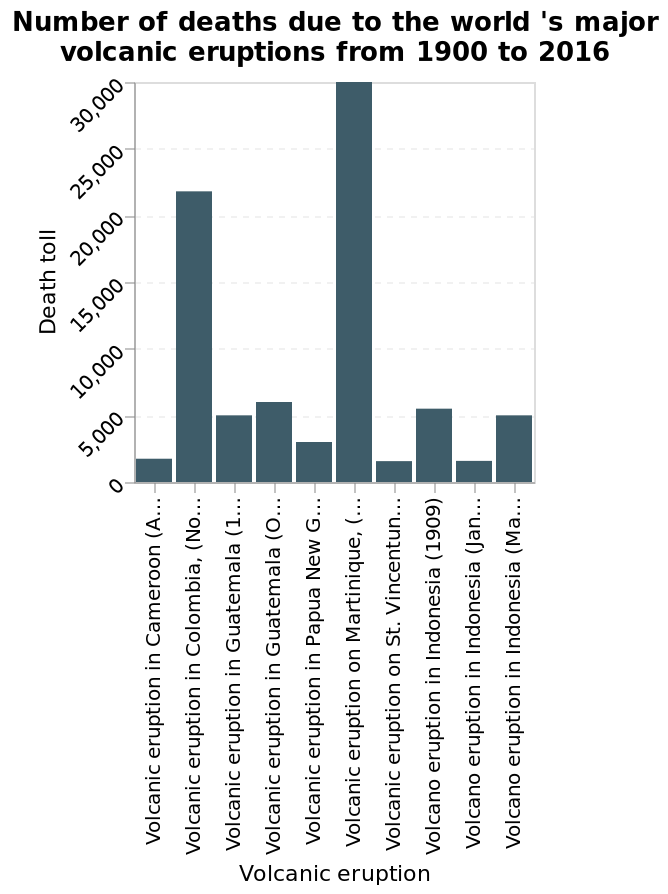<image>
What does the y-axis represent in the bar diagram?  The y-axis represents the Death toll. What event in Martinique resulted in the greatest number of deaths? The volcanic eruption on Martinique had the highest death toll. Describe the following image in detail Here a bar diagram is named Number of deaths due to the world 's major volcanic eruptions from 1900 to 2016. The y-axis shows Death toll while the x-axis shows Volcanic eruption. please summary the statistics and relations of the chart Volcanic eruptions in Martinique have caused the most number of death between 1900 - 2016. The least number of deaths was in St Vincent. Did the volcanic eruption on Martinique have the lowest death toll? No.The volcanic eruption on Martinique had the highest death toll. 